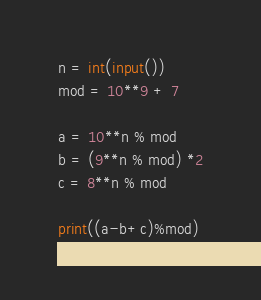Convert code to text. <code><loc_0><loc_0><loc_500><loc_500><_Python_>n = int(input())
mod = 10**9 + 7

a = 10**n % mod
b = (9**n % mod) *2
c = 8**n % mod

print((a-b+c)%mod)
</code> 